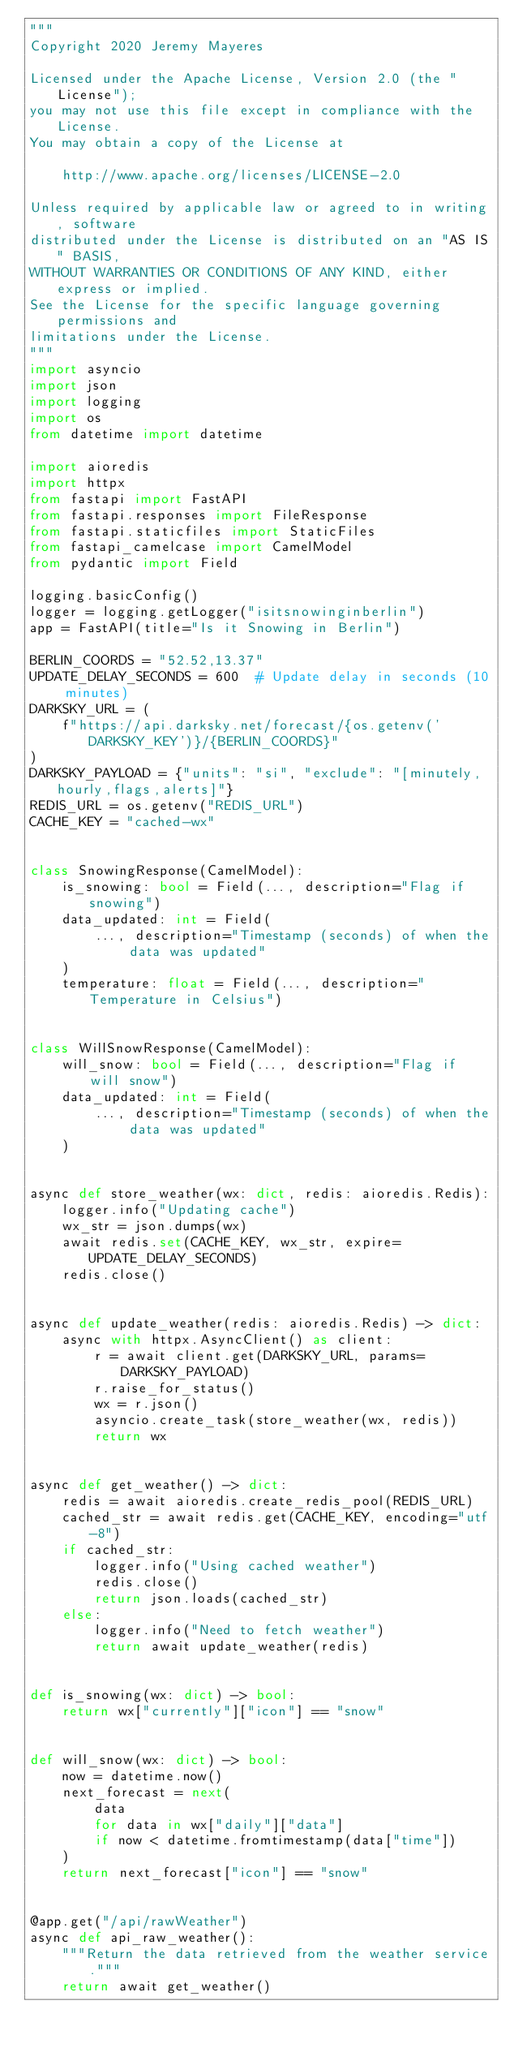<code> <loc_0><loc_0><loc_500><loc_500><_Python_>"""
Copyright 2020 Jeremy Mayeres

Licensed under the Apache License, Version 2.0 (the "License");
you may not use this file except in compliance with the License.
You may obtain a copy of the License at

    http://www.apache.org/licenses/LICENSE-2.0

Unless required by applicable law or agreed to in writing, software
distributed under the License is distributed on an "AS IS" BASIS,
WITHOUT WARRANTIES OR CONDITIONS OF ANY KIND, either express or implied.
See the License for the specific language governing permissions and
limitations under the License.
"""
import asyncio
import json
import logging
import os
from datetime import datetime

import aioredis
import httpx
from fastapi import FastAPI
from fastapi.responses import FileResponse
from fastapi.staticfiles import StaticFiles
from fastapi_camelcase import CamelModel
from pydantic import Field

logging.basicConfig()
logger = logging.getLogger("isitsnowinginberlin")
app = FastAPI(title="Is it Snowing in Berlin")

BERLIN_COORDS = "52.52,13.37"
UPDATE_DELAY_SECONDS = 600  # Update delay in seconds (10 minutes)
DARKSKY_URL = (
    f"https://api.darksky.net/forecast/{os.getenv('DARKSKY_KEY')}/{BERLIN_COORDS}"
)
DARKSKY_PAYLOAD = {"units": "si", "exclude": "[minutely,hourly,flags,alerts]"}
REDIS_URL = os.getenv("REDIS_URL")
CACHE_KEY = "cached-wx"


class SnowingResponse(CamelModel):
    is_snowing: bool = Field(..., description="Flag if snowing")
    data_updated: int = Field(
        ..., description="Timestamp (seconds) of when the data was updated"
    )
    temperature: float = Field(..., description="Temperature in Celsius")


class WillSnowResponse(CamelModel):
    will_snow: bool = Field(..., description="Flag if will snow")
    data_updated: int = Field(
        ..., description="Timestamp (seconds) of when the data was updated"
    )


async def store_weather(wx: dict, redis: aioredis.Redis):
    logger.info("Updating cache")
    wx_str = json.dumps(wx)
    await redis.set(CACHE_KEY, wx_str, expire=UPDATE_DELAY_SECONDS)
    redis.close()


async def update_weather(redis: aioredis.Redis) -> dict:
    async with httpx.AsyncClient() as client:
        r = await client.get(DARKSKY_URL, params=DARKSKY_PAYLOAD)
        r.raise_for_status()
        wx = r.json()
        asyncio.create_task(store_weather(wx, redis))
        return wx


async def get_weather() -> dict:
    redis = await aioredis.create_redis_pool(REDIS_URL)
    cached_str = await redis.get(CACHE_KEY, encoding="utf-8")
    if cached_str:
        logger.info("Using cached weather")
        redis.close()
        return json.loads(cached_str)
    else:
        logger.info("Need to fetch weather")
        return await update_weather(redis)


def is_snowing(wx: dict) -> bool:
    return wx["currently"]["icon"] == "snow"


def will_snow(wx: dict) -> bool:
    now = datetime.now()
    next_forecast = next(
        data
        for data in wx["daily"]["data"]
        if now < datetime.fromtimestamp(data["time"])
    )
    return next_forecast["icon"] == "snow"


@app.get("/api/rawWeather")
async def api_raw_weather():
    """Return the data retrieved from the weather service."""
    return await get_weather()

</code> 